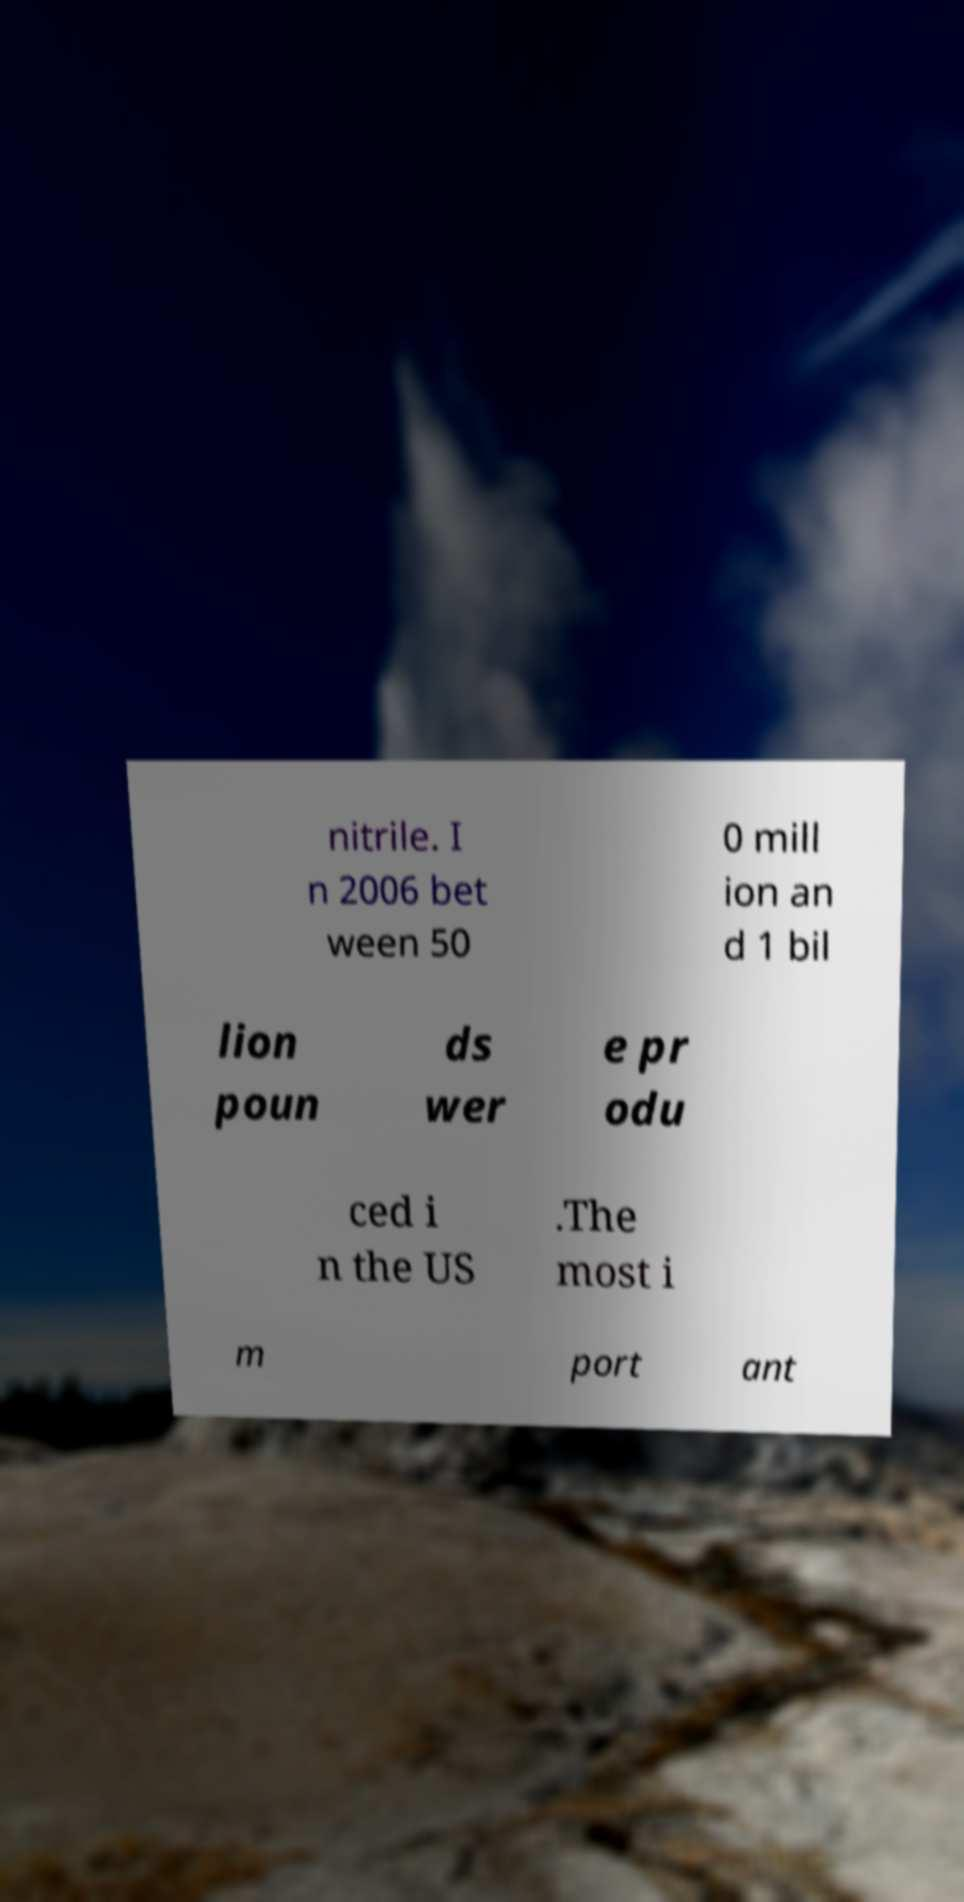Can you read and provide the text displayed in the image?This photo seems to have some interesting text. Can you extract and type it out for me? nitrile. I n 2006 bet ween 50 0 mill ion an d 1 bil lion poun ds wer e pr odu ced i n the US .The most i m port ant 